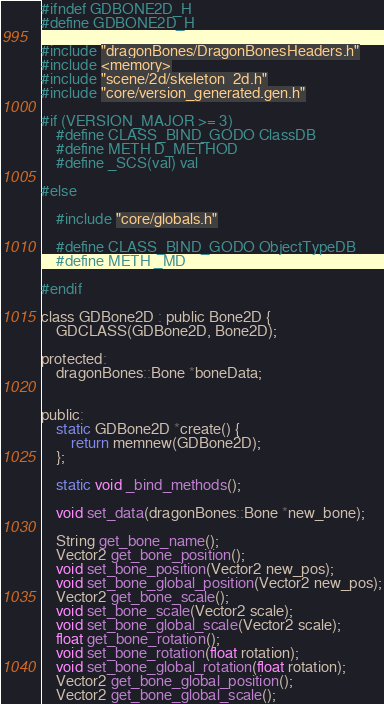Convert code to text. <code><loc_0><loc_0><loc_500><loc_500><_C_>#ifndef GDBONE2D_H
#define GDBONE2D_H

#include "dragonBones/DragonBonesHeaders.h"
#include <memory>
#include "scene/2d/skeleton_2d.h"
#include "core/version_generated.gen.h"

#if (VERSION_MAJOR >= 3)
	#define CLASS_BIND_GODO ClassDB
	#define METH D_METHOD
	#define _SCS(val) val

#else

	#include "core/globals.h"

	#define CLASS_BIND_GODO ObjectTypeDB
	#define METH _MD

#endif

class GDBone2D : public Bone2D {
	GDCLASS(GDBone2D, Bone2D);

protected:
	dragonBones::Bone *boneData;


public:
	static GDBone2D *create() {
		return memnew(GDBone2D);
	};

	static void _bind_methods();

	void set_data(dragonBones::Bone *new_bone);

	String get_bone_name();
	Vector2 get_bone_position();
	void set_bone_position(Vector2 new_pos);
	void set_bone_global_position(Vector2 new_pos);
	Vector2 get_bone_scale();
	void set_bone_scale(Vector2 scale);
	void set_bone_global_scale(Vector2 scale);
	float get_bone_rotation();
	void set_bone_rotation(float rotation);
	void set_bone_global_rotation(float rotation);
	Vector2 get_bone_global_position();
	Vector2 get_bone_global_scale();</code> 